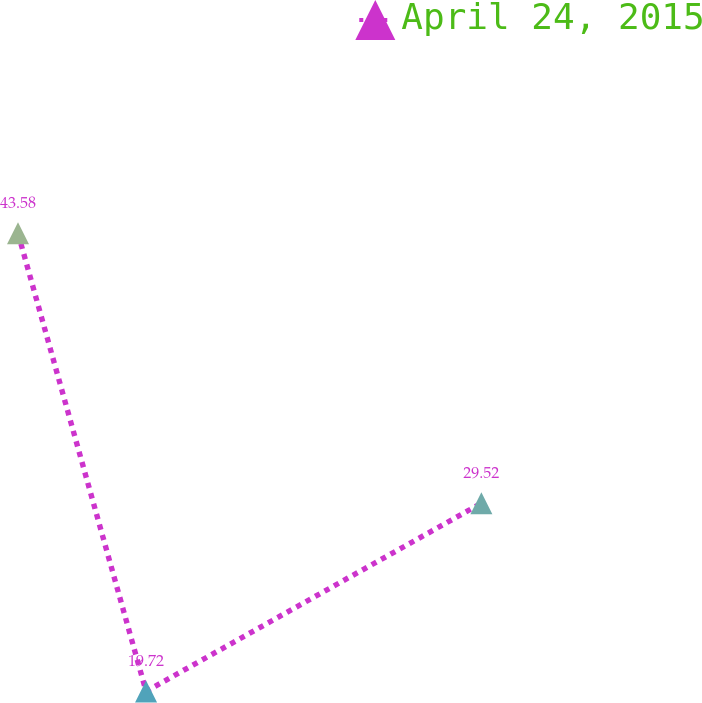Convert chart to OTSL. <chart><loc_0><loc_0><loc_500><loc_500><line_chart><ecel><fcel>April 24, 2015<nl><fcel>19.51<fcel>43.58<nl><fcel>29.07<fcel>19.72<nl><fcel>54.1<fcel>29.52<nl><fcel>115.06<fcel>117.72<nl></chart> 